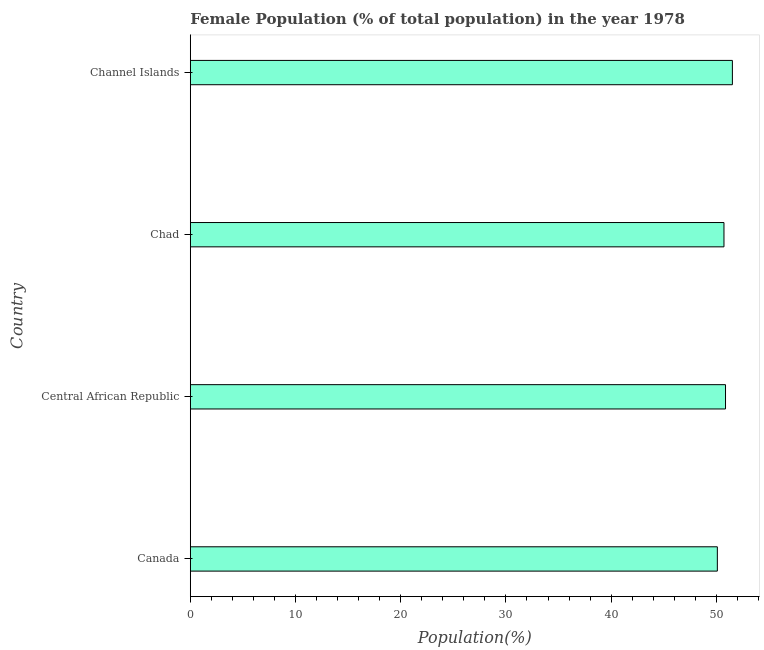What is the title of the graph?
Your answer should be very brief. Female Population (% of total population) in the year 1978. What is the label or title of the X-axis?
Offer a very short reply. Population(%). What is the female population in Chad?
Provide a short and direct response. 50.73. Across all countries, what is the maximum female population?
Your response must be concise. 51.53. Across all countries, what is the minimum female population?
Your answer should be very brief. 50.1. In which country was the female population maximum?
Your answer should be very brief. Channel Islands. In which country was the female population minimum?
Your answer should be compact. Canada. What is the sum of the female population?
Offer a terse response. 203.22. What is the difference between the female population in Canada and Central African Republic?
Your response must be concise. -0.78. What is the average female population per country?
Ensure brevity in your answer.  50.81. What is the median female population?
Keep it short and to the point. 50.8. In how many countries, is the female population greater than 22 %?
Offer a very short reply. 4. Is the female population in Canada less than that in Chad?
Your answer should be very brief. Yes. What is the difference between the highest and the second highest female population?
Ensure brevity in your answer.  0.65. What is the difference between the highest and the lowest female population?
Your response must be concise. 1.43. How many countries are there in the graph?
Your answer should be compact. 4. What is the difference between two consecutive major ticks on the X-axis?
Keep it short and to the point. 10. What is the Population(%) in Canada?
Your response must be concise. 50.1. What is the Population(%) in Central African Republic?
Offer a terse response. 50.87. What is the Population(%) in Chad?
Give a very brief answer. 50.73. What is the Population(%) of Channel Islands?
Your response must be concise. 51.53. What is the difference between the Population(%) in Canada and Central African Republic?
Your response must be concise. -0.78. What is the difference between the Population(%) in Canada and Chad?
Offer a very short reply. -0.63. What is the difference between the Population(%) in Canada and Channel Islands?
Offer a very short reply. -1.43. What is the difference between the Population(%) in Central African Republic and Chad?
Your answer should be compact. 0.15. What is the difference between the Population(%) in Central African Republic and Channel Islands?
Provide a short and direct response. -0.65. What is the difference between the Population(%) in Chad and Channel Islands?
Provide a succinct answer. -0.8. What is the ratio of the Population(%) in Canada to that in Central African Republic?
Ensure brevity in your answer.  0.98. What is the ratio of the Population(%) in Canada to that in Chad?
Offer a very short reply. 0.99. What is the ratio of the Population(%) in Canada to that in Channel Islands?
Your answer should be compact. 0.97. What is the ratio of the Population(%) in Central African Republic to that in Channel Islands?
Ensure brevity in your answer.  0.99. What is the ratio of the Population(%) in Chad to that in Channel Islands?
Give a very brief answer. 0.98. 